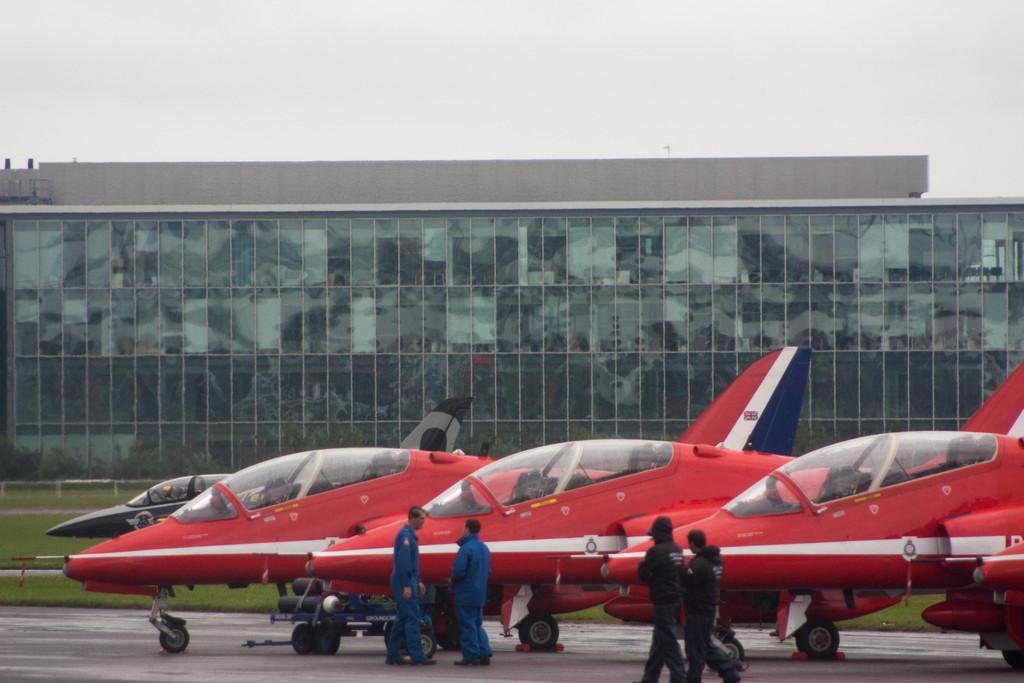What objects are on the floor in the image? There are aircrafts on the floor in the image. What can be seen in the image besides the aircrafts? There are persons standing in the image. What is visible in the background of the image? The sky, buildings, plants, and the ground are visible in the background of the image. Can you describe the iron rod in the background of the image? There is an iron rod in the background of the image. How many kittens are playing with a nail in the image? There are no kittens or nails present in the image. 